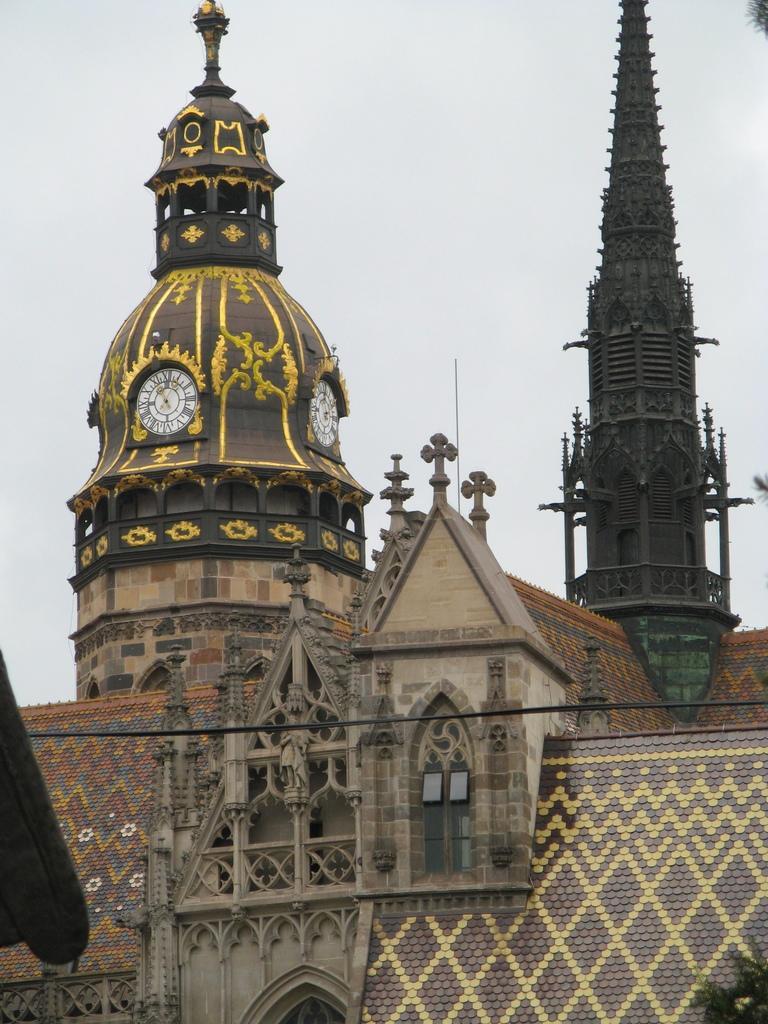Could you give a brief overview of what you see in this image? In this image in the center there are buildings and there are towers and the sky is cloudy. On the tower which is on the left side there are clocks and there is an object on the left side which is visible. On the right side there is an object which is black in colour and on the top right there are leaves. 